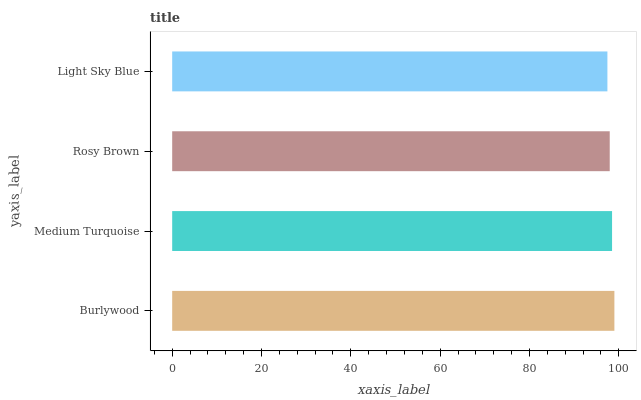Is Light Sky Blue the minimum?
Answer yes or no. Yes. Is Burlywood the maximum?
Answer yes or no. Yes. Is Medium Turquoise the minimum?
Answer yes or no. No. Is Medium Turquoise the maximum?
Answer yes or no. No. Is Burlywood greater than Medium Turquoise?
Answer yes or no. Yes. Is Medium Turquoise less than Burlywood?
Answer yes or no. Yes. Is Medium Turquoise greater than Burlywood?
Answer yes or no. No. Is Burlywood less than Medium Turquoise?
Answer yes or no. No. Is Medium Turquoise the high median?
Answer yes or no. Yes. Is Rosy Brown the low median?
Answer yes or no. Yes. Is Rosy Brown the high median?
Answer yes or no. No. Is Medium Turquoise the low median?
Answer yes or no. No. 